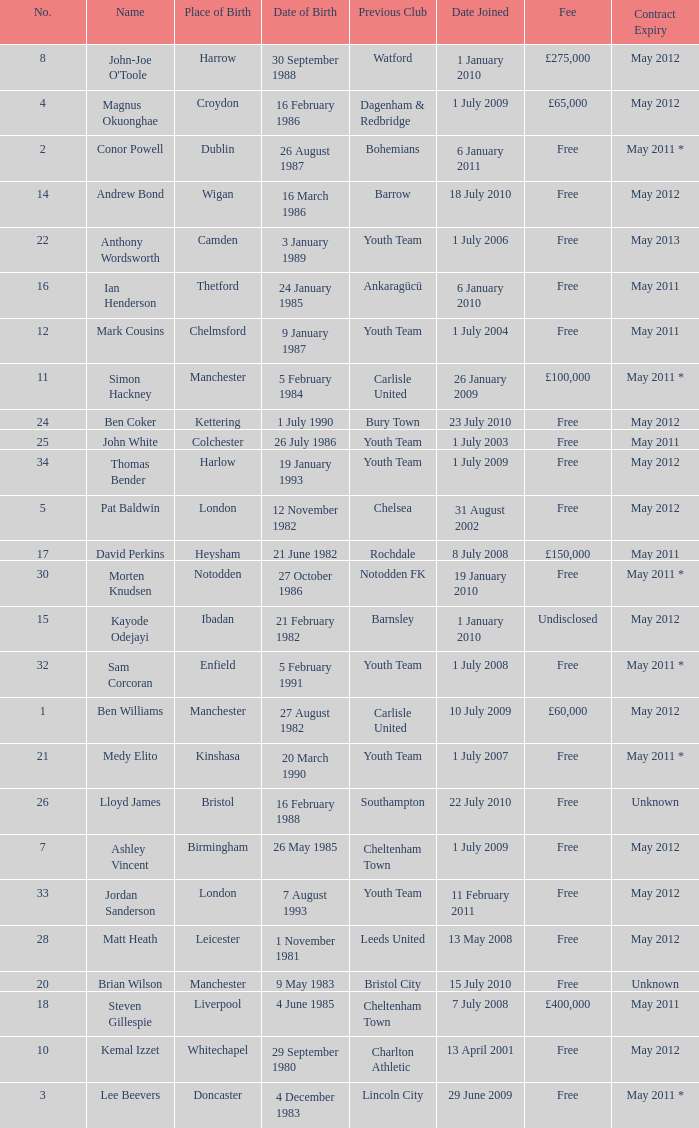For the ben williams name what was the previous club Carlisle United. 